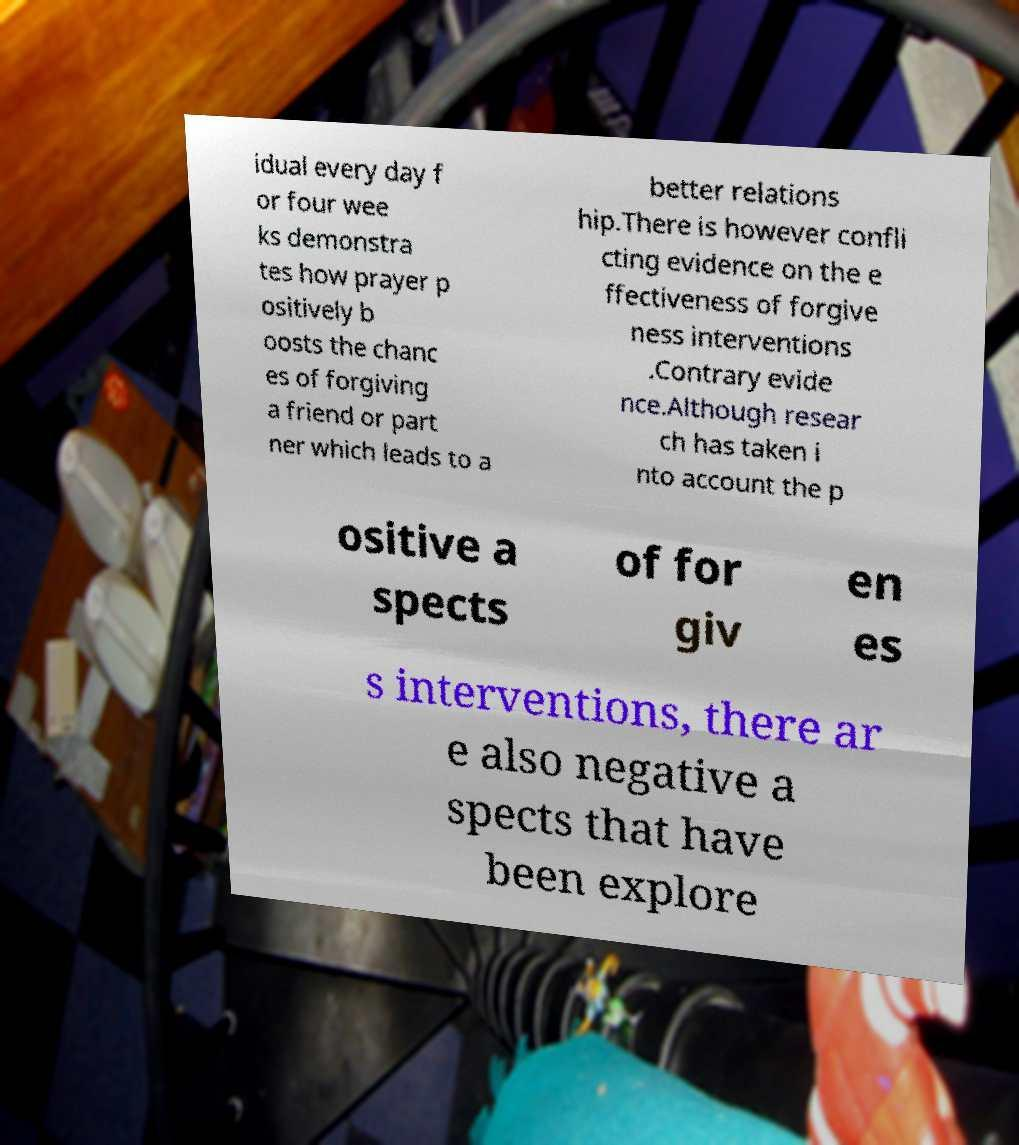Please read and relay the text visible in this image. What does it say? idual every day f or four wee ks demonstra tes how prayer p ositively b oosts the chanc es of forgiving a friend or part ner which leads to a better relations hip.There is however confli cting evidence on the e ffectiveness of forgive ness interventions .Contrary evide nce.Although resear ch has taken i nto account the p ositive a spects of for giv en es s interventions, there ar e also negative a spects that have been explore 